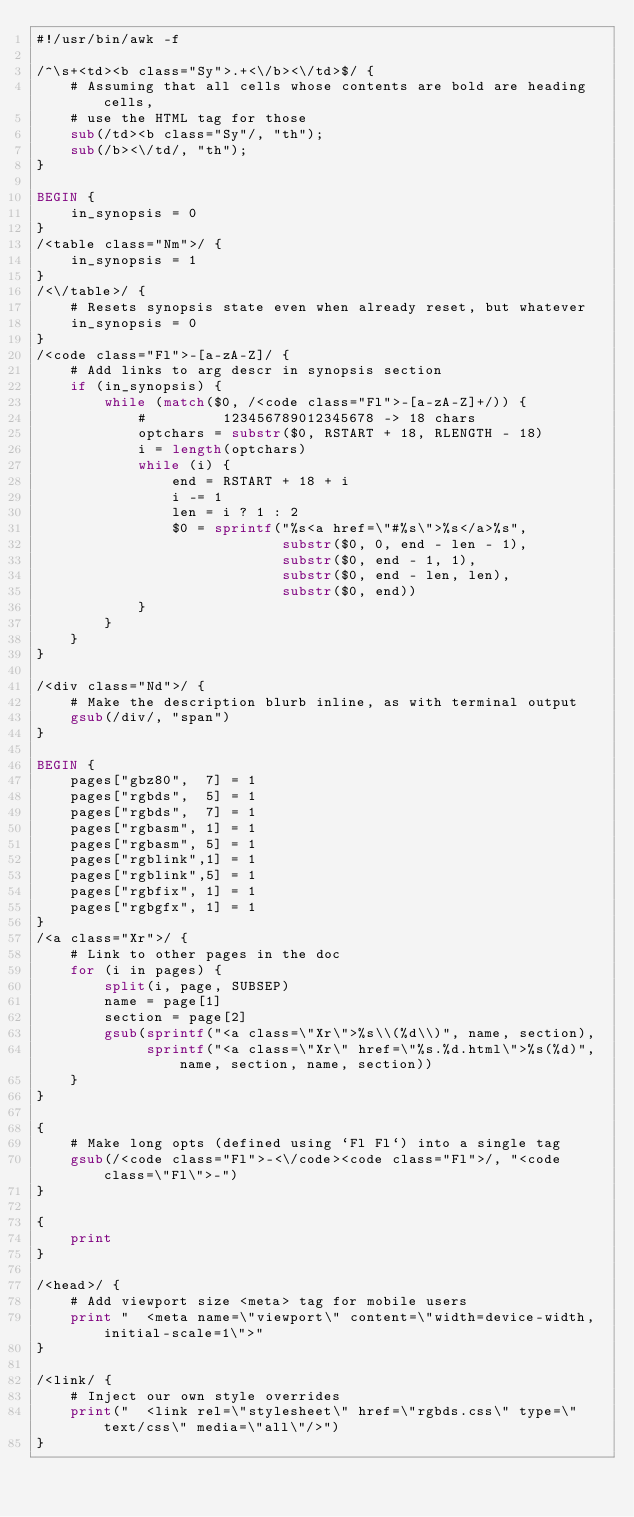Convert code to text. <code><loc_0><loc_0><loc_500><loc_500><_Awk_>#!/usr/bin/awk -f

/^\s+<td><b class="Sy">.+<\/b><\/td>$/ {
	# Assuming that all cells whose contents are bold are heading cells,
	# use the HTML tag for those
	sub(/td><b class="Sy"/, "th");
	sub(/b><\/td/, "th");
}

BEGIN {
	in_synopsis = 0
}
/<table class="Nm">/ {
	in_synopsis = 1
}
/<\/table>/ {
	# Resets synopsis state even when already reset, but whatever
	in_synopsis = 0
}
/<code class="Fl">-[a-zA-Z]/ {
	# Add links to arg descr in synopsis section
	if (in_synopsis) {
		while (match($0, /<code class="Fl">-[a-zA-Z]+/)) {
			#         123456789012345678 -> 18 chars
			optchars = substr($0, RSTART + 18, RLENGTH - 18)
			i = length(optchars)
			while (i) {
				end = RSTART + 18 + i
				i -= 1
				len = i ? 1 : 2
				$0 = sprintf("%s<a href=\"#%s\">%s</a>%s",
				             substr($0, 0, end - len - 1),
				             substr($0, end - 1, 1),
				             substr($0, end - len, len),
				             substr($0, end))
			}
		}
	}
}

/<div class="Nd">/ {
	# Make the description blurb inline, as with terminal output
	gsub(/div/, "span")
}

BEGIN {
	pages["gbz80",  7] = 1
	pages["rgbds",  5] = 1
	pages["rgbds",  7] = 1
	pages["rgbasm", 1] = 1
	pages["rgbasm", 5] = 1
	pages["rgblink",1] = 1
	pages["rgblink",5] = 1
	pages["rgbfix", 1] = 1
	pages["rgbgfx", 1] = 1
}
/<a class="Xr">/ {
	# Link to other pages in the doc
	for (i in pages) {
		split(i, page, SUBSEP)
		name = page[1]
		section = page[2]
		gsub(sprintf("<a class=\"Xr\">%s\\(%d\\)", name, section),
		     sprintf("<a class=\"Xr\" href=\"%s.%d.html\">%s(%d)", name, section, name, section))
	}
}

{
	# Make long opts (defined using `Fl Fl`) into a single tag
	gsub(/<code class="Fl">-<\/code><code class="Fl">/, "<code class=\"Fl\">-")
}

{
	print
}

/<head>/ {
	# Add viewport size <meta> tag for mobile users
	print "  <meta name=\"viewport\" content=\"width=device-width, initial-scale=1\">"
}

/<link/ {
	# Inject our own style overrides
	print("  <link rel=\"stylesheet\" href=\"rgbds.css\" type=\"text/css\" media=\"all\"/>")
}
</code> 